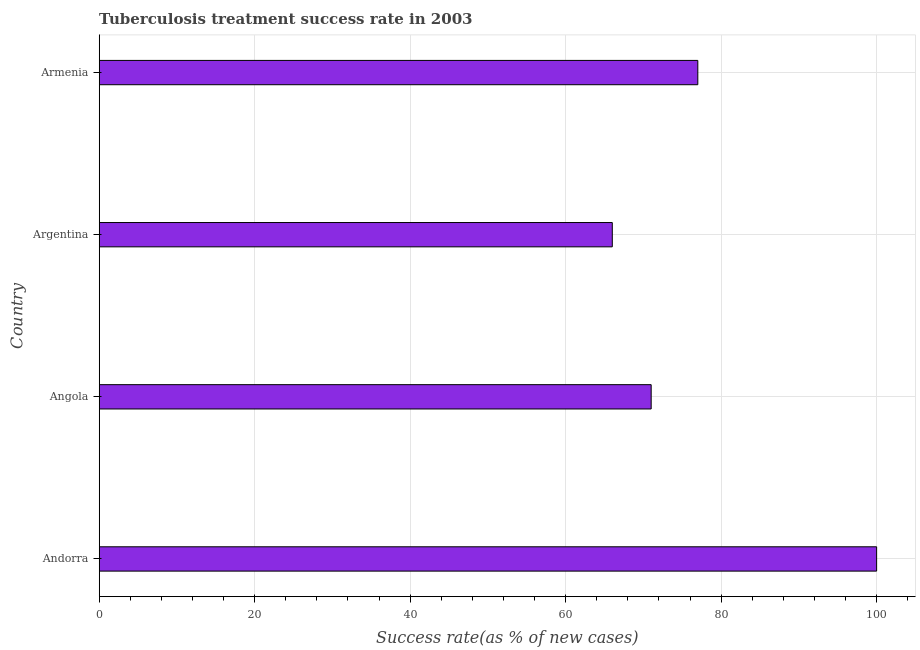What is the title of the graph?
Your answer should be compact. Tuberculosis treatment success rate in 2003. What is the label or title of the X-axis?
Keep it short and to the point. Success rate(as % of new cases). Across all countries, what is the minimum tuberculosis treatment success rate?
Keep it short and to the point. 66. In which country was the tuberculosis treatment success rate maximum?
Provide a succinct answer. Andorra. In which country was the tuberculosis treatment success rate minimum?
Provide a succinct answer. Argentina. What is the sum of the tuberculosis treatment success rate?
Your answer should be very brief. 314. What is the median tuberculosis treatment success rate?
Offer a terse response. 74. In how many countries, is the tuberculosis treatment success rate greater than 76 %?
Offer a very short reply. 2. What is the ratio of the tuberculosis treatment success rate in Andorra to that in Armenia?
Ensure brevity in your answer.  1.3. Is the tuberculosis treatment success rate in Angola less than that in Armenia?
Your answer should be very brief. Yes. What is the difference between the highest and the second highest tuberculosis treatment success rate?
Keep it short and to the point. 23. Is the sum of the tuberculosis treatment success rate in Andorra and Armenia greater than the maximum tuberculosis treatment success rate across all countries?
Give a very brief answer. Yes. What is the difference between the highest and the lowest tuberculosis treatment success rate?
Give a very brief answer. 34. In how many countries, is the tuberculosis treatment success rate greater than the average tuberculosis treatment success rate taken over all countries?
Offer a terse response. 1. Are all the bars in the graph horizontal?
Provide a short and direct response. Yes. What is the difference between two consecutive major ticks on the X-axis?
Make the answer very short. 20. What is the Success rate(as % of new cases) in Angola?
Give a very brief answer. 71. What is the difference between the Success rate(as % of new cases) in Andorra and Armenia?
Provide a short and direct response. 23. What is the difference between the Success rate(as % of new cases) in Angola and Argentina?
Provide a short and direct response. 5. What is the ratio of the Success rate(as % of new cases) in Andorra to that in Angola?
Your response must be concise. 1.41. What is the ratio of the Success rate(as % of new cases) in Andorra to that in Argentina?
Make the answer very short. 1.51. What is the ratio of the Success rate(as % of new cases) in Andorra to that in Armenia?
Keep it short and to the point. 1.3. What is the ratio of the Success rate(as % of new cases) in Angola to that in Argentina?
Offer a terse response. 1.08. What is the ratio of the Success rate(as % of new cases) in Angola to that in Armenia?
Your answer should be compact. 0.92. What is the ratio of the Success rate(as % of new cases) in Argentina to that in Armenia?
Offer a terse response. 0.86. 